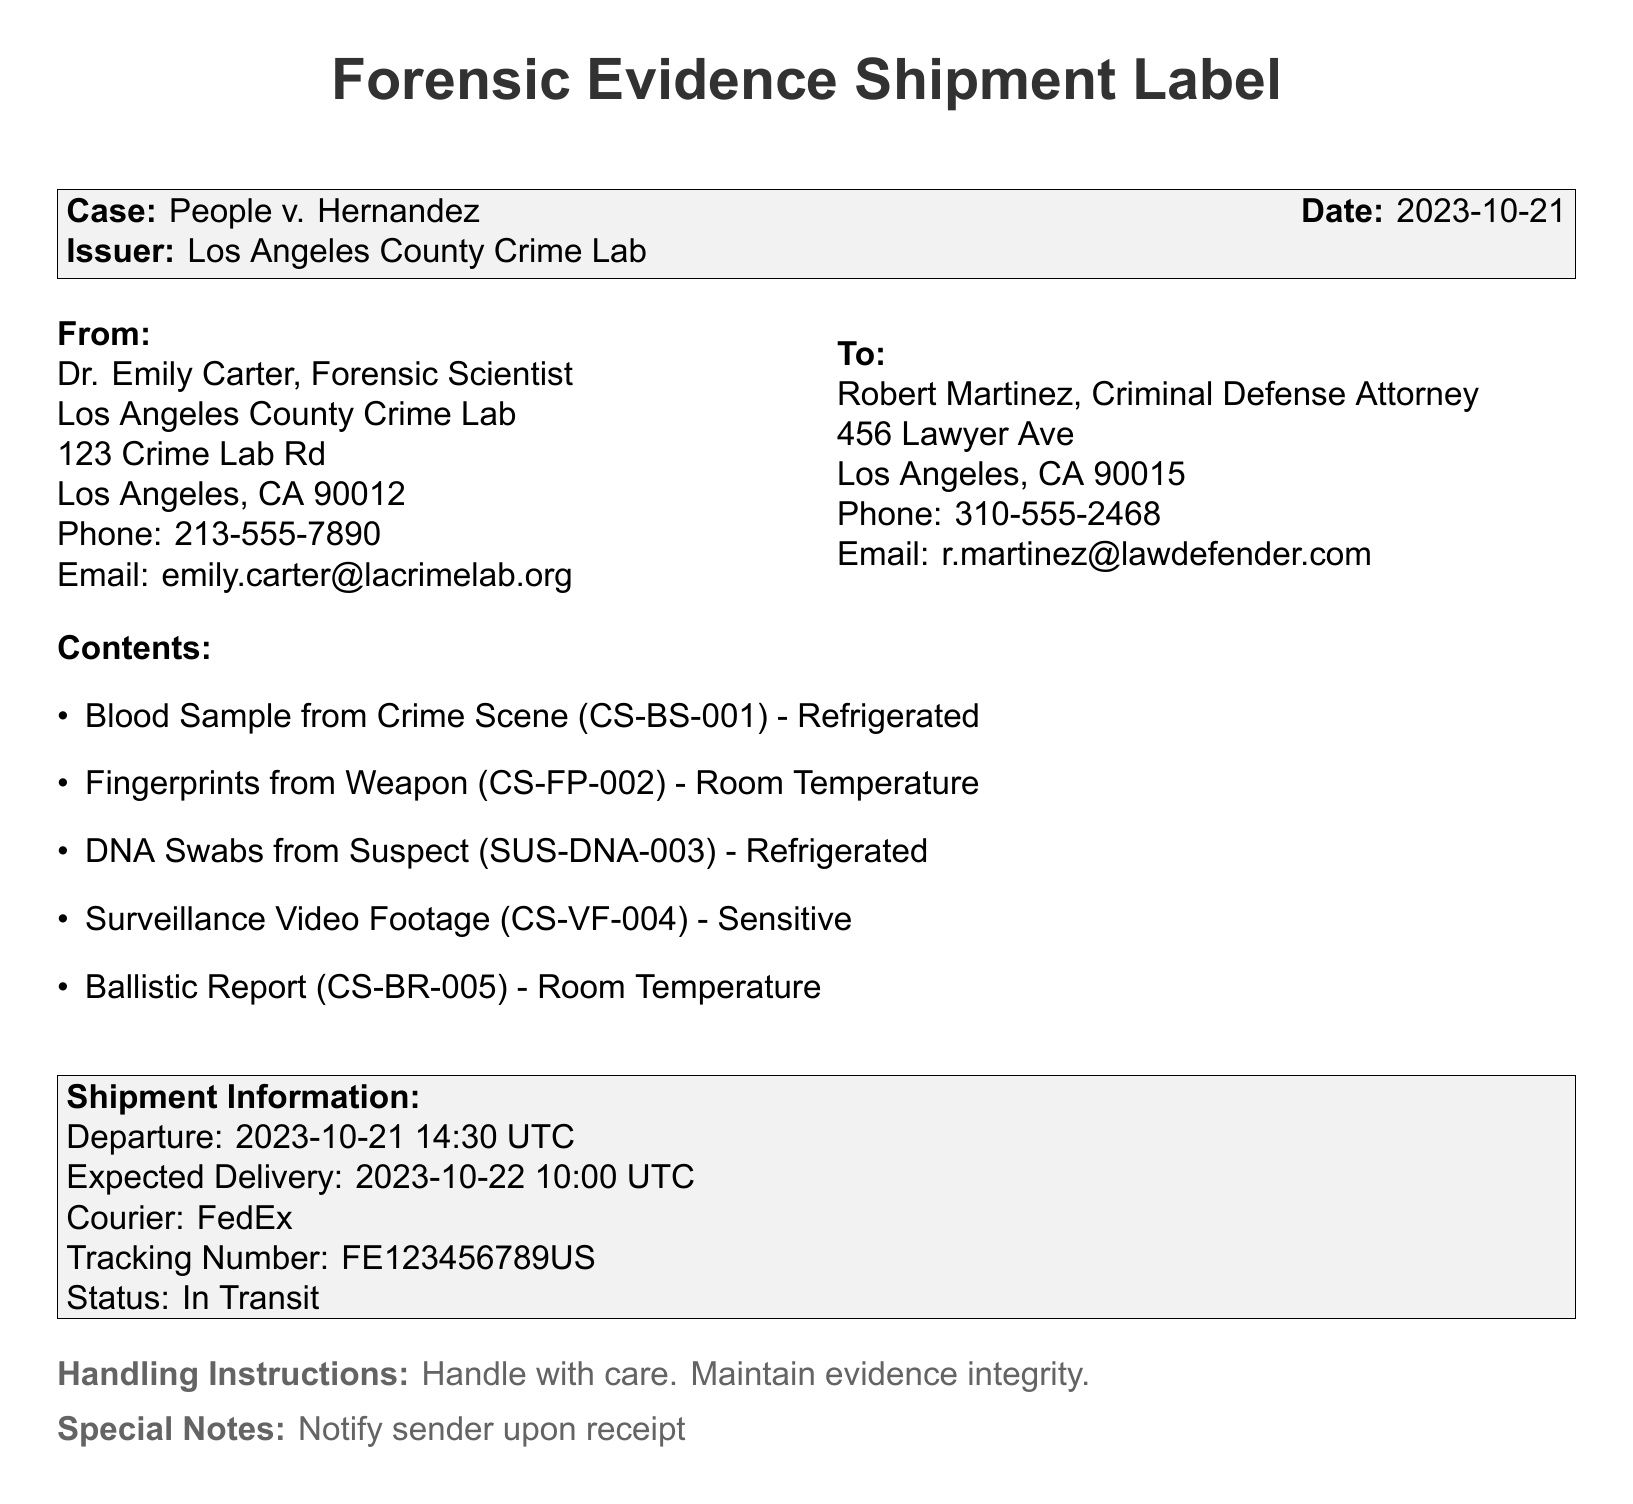What is the case name? The case name is listed at the top of the document following the title, identifying the specific legal case involved.
Answer: People v. Hernandez Who issued the forensic evidence package? The issuer is provided in the document, indicating the authority responsible for sending the package.
Answer: Los Angeles County Crime Lab What is the email address of the sender? The sender's email is located in the contact information section for Dr. Emily Carter.
Answer: emily.carter@lacrimelab.org What is the expected delivery date? The expected delivery date is stated in the shipment information section, indicating when the package should arrive.
Answer: 2023-10-22 How many items are listed in the contents? The number of items can be counted from the contents list provided in the document.
Answer: Five What type of evidence is the blood sample? The type of evidence is identified by its description in the contents list, indicating specific evidence requirements.
Answer: Refrigerated Who is the recipient of the shipment? The recipient's name is found in the "To" section of the document, specifying the individual receiving the evidence.
Answer: Robert Martinez What is the shipment status? The current status of the shipment is detailed in the shipment information section, indicating the package's movement.
Answer: In Transit What are the special notes regarding handling? The special notes are provided at the bottom of the document, outlining requirements for those handling the evidence.
Answer: Notify sender upon receipt 